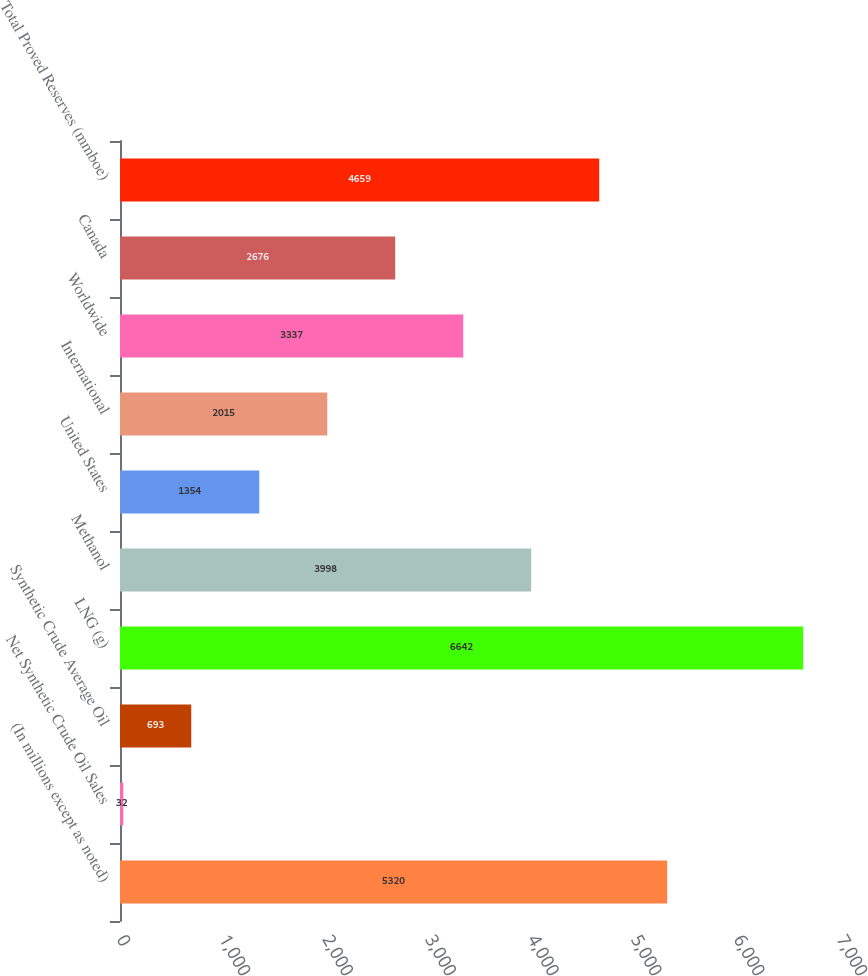<chart> <loc_0><loc_0><loc_500><loc_500><bar_chart><fcel>(In millions except as noted)<fcel>Net Synthetic Crude Oil Sales<fcel>Synthetic Crude Average Oil<fcel>LNG (g)<fcel>Methanol<fcel>United States<fcel>International<fcel>Worldwide<fcel>Canada<fcel>Total Proved Reserves (mmboe)<nl><fcel>5320<fcel>32<fcel>693<fcel>6642<fcel>3998<fcel>1354<fcel>2015<fcel>3337<fcel>2676<fcel>4659<nl></chart> 